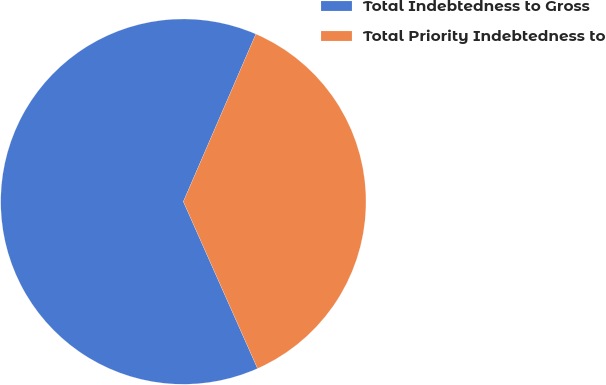Convert chart. <chart><loc_0><loc_0><loc_500><loc_500><pie_chart><fcel>Total Indebtedness to Gross<fcel>Total Priority Indebtedness to<nl><fcel>63.16%<fcel>36.84%<nl></chart> 